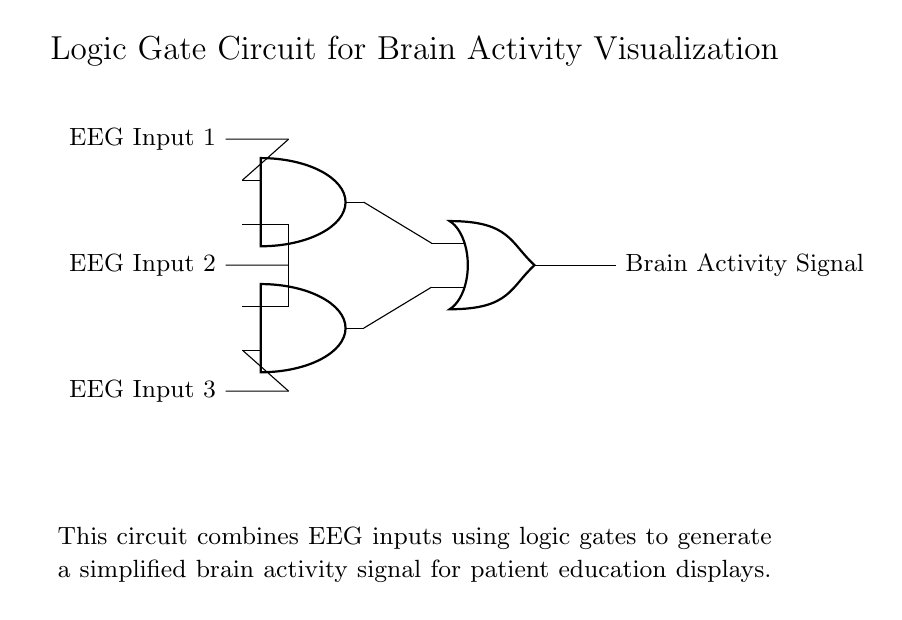What are the inputs to the circuit? The inputs to the circuit are three EEG inputs labeled as EEG Input 1, EEG Input 2, and EEG Input 3. They are represented on the left side of the circuit diagram.
Answer: EEG Input 1, EEG Input 2, EEG Input 3 What type of logic gates are used in this circuit? The circuit uses two AND gates and one OR gate. This can be identified by the symbols labeled 'and port' and 'or port' depicted in the circuit.
Answer: AND gates and OR gate How many connections are there from the inputs to the AND gates? There are four connections from the inputs to the AND gates: two connect to the first AND gate and two connect to the second. This can be counted by observing the lines connecting the input nodes to the gates.
Answer: Four What is the output of the OR gate? The output of the OR gate is labeled as "Brain Activity Signal," which indicates the final output generated by processing the inputs through the AND and OR gates.
Answer: Brain Activity Signal How many outputs does the circuit produce? The circuit produces one output, which is the result from the OR gate. This can be determined by looking at the output line that emerges from the OR gate node.
Answer: One Which inputs are connected to the first AND gate? The first AND gate receives input from EEG Input 1 and EEG Input 2, as shown by the lines leading to this gate.
Answer: EEG Input 1, EEG Input 2 What operation does the OR gate perform on the signals from the AND gates? The OR gate performs a logical OR operation on the output signals from the two AND gates, which can be inferred from its function as an OR gate in digital logic.
Answer: Logical OR operation 